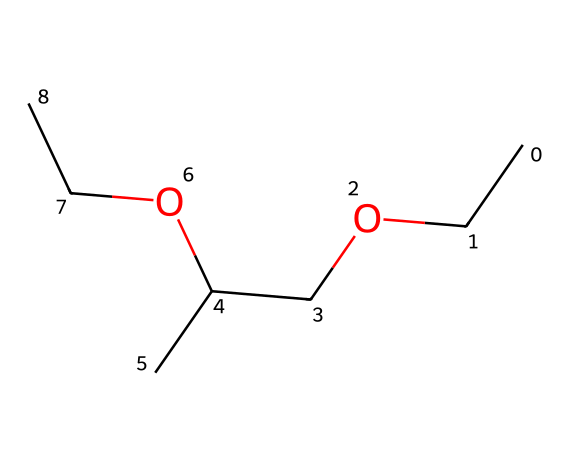How many carbon atoms are present in this chemical? By analyzing the SMILES representation, we can identify each carbon atom represented by 'C'. Counting these, we find there are 6 carbon atoms overall in the structure.
Answer: 6 What type of functional group is prominent in this chemical? The presence of the ether bond (R-O-R') is indicated by the structure where oxygen is bonded to carbon chains on both sides. This structure is typical of ethers, which feature an oxygen atom bonded to two alkyl or aryl groups.
Answer: ether What is the total number of oxygen atoms in the chemical? The SMILES representation shows 'O' appearing twice, indicating there are two oxygen atoms present in the structure.
Answer: 2 Which part of the chemical structure makes it suitable as a solvent in perfumes? The ether part of the molecule (the O between carbon chains) allows it to dissolve various organic compounds and fragrances due to its polar and nonpolar regions, enhancing its solvent properties in many perfumery applications.
Answer: ether portion What is the molecular formula derived from this SMILES? To derive the molecular formula, we count the carbons (C), hydrogens (H), and oxygens (O) directly from the SMILES. There are 6 carbons, 14 hydrogens, and 2 oxygens, giving us the formula C6H14O2.
Answer: C6H14O2 How might this chemical interact with water based on its structure? Due to the presence of oxygen and the polar nature of ether bonds, ethylene glycol diethyl ether can engage in dipole-dipole interactions with water, allowing for partial miscibility in polar solvents.
Answer: partially miscible 